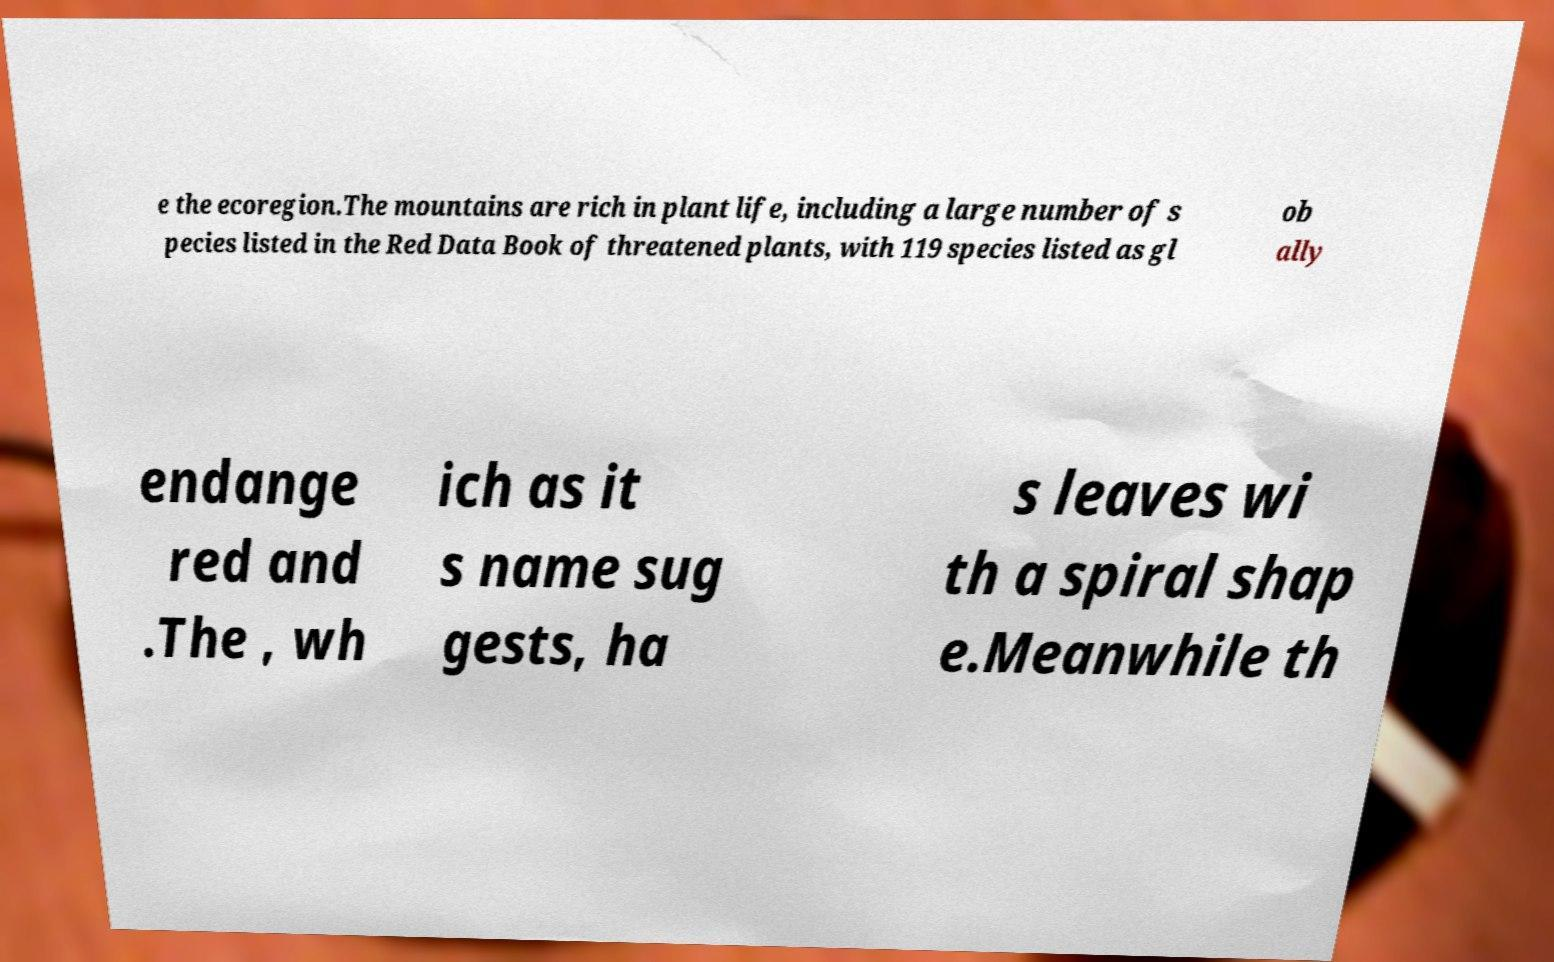For documentation purposes, I need the text within this image transcribed. Could you provide that? e the ecoregion.The mountains are rich in plant life, including a large number of s pecies listed in the Red Data Book of threatened plants, with 119 species listed as gl ob ally endange red and .The , wh ich as it s name sug gests, ha s leaves wi th a spiral shap e.Meanwhile th 